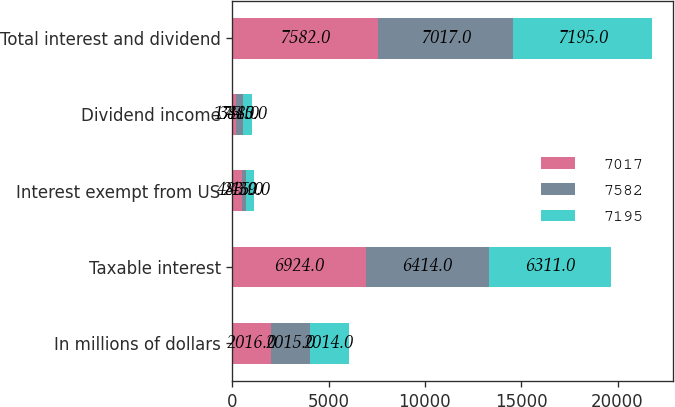Convert chart. <chart><loc_0><loc_0><loc_500><loc_500><stacked_bar_chart><ecel><fcel>In millions of dollars<fcel>Taxable interest<fcel>Interest exempt from US<fcel>Dividend income<fcel>Total interest and dividend<nl><fcel>7017<fcel>2016<fcel>6924<fcel>483<fcel>175<fcel>7582<nl><fcel>7582<fcel>2015<fcel>6414<fcel>215<fcel>388<fcel>7017<nl><fcel>7195<fcel>2014<fcel>6311<fcel>439<fcel>445<fcel>7195<nl></chart> 